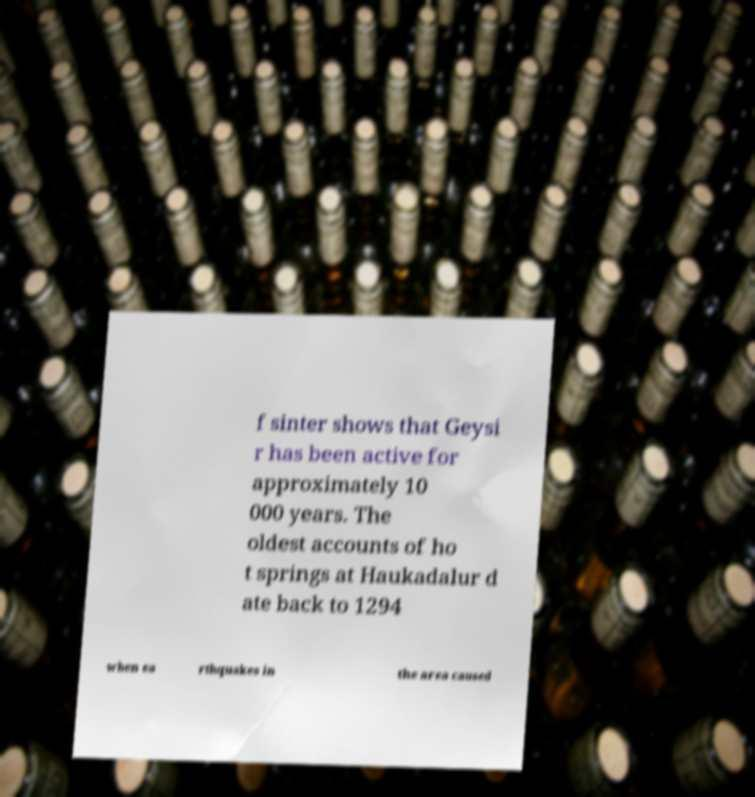I need the written content from this picture converted into text. Can you do that? f sinter shows that Geysi r has been active for approximately 10 000 years. The oldest accounts of ho t springs at Haukadalur d ate back to 1294 when ea rthquakes in the area caused 